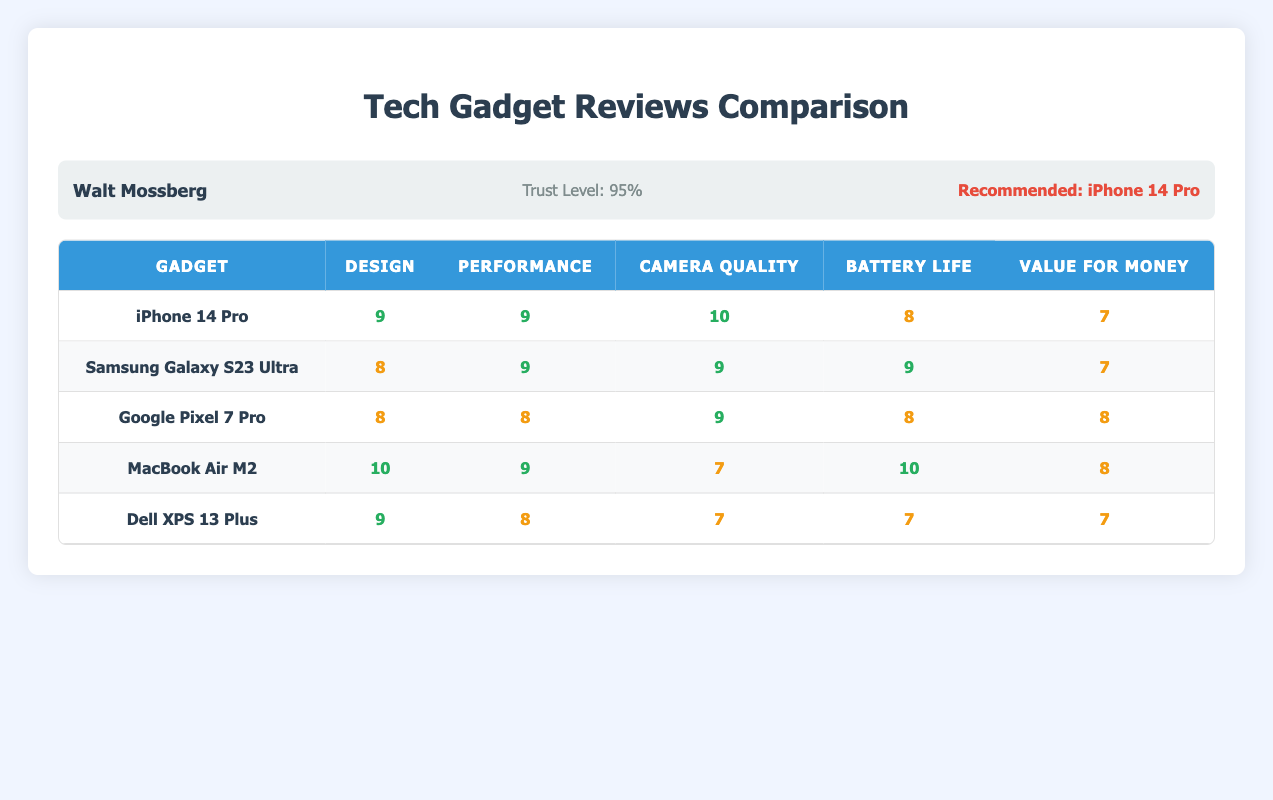What did Walt Mossberg rate the Camera Quality of the iPhone 14 Pro? According to the table, Walt Mossberg rated the Camera Quality of the iPhone 14 Pro as 10.
Answer: 10 Which gadget received the highest overall rating in Design from all columnists? Looking at the Design ratings, the MacBook Air M2 received a score of 10 from Walt Mossberg and a score of 10 from David Pogue, which are the highest ratings for Design across all columnists.
Answer: MacBook Air M2 Does David Pogue think the Samsung Galaxy S23 Ultra has better Camera Quality than the Google Pixel 7 Pro? Yes, David Pogue rated the Camera Quality of the Samsung Galaxy S23 Ultra as 10, while the Google Pixel 7 Pro received a rating of 9 for Camera Quality.
Answer: Yes What is the average Battery Life rating for the Dell XPS 13 Plus? The ratings for the Dell XPS 13 Plus's Battery Life from all columnists are: Walt Mossberg (7), David Pogue (7), Joanna Stern (7), Marques Brownlee (7), and Lisa Eadicicco (7). Summing these gives 35, and dividing by 5 yields an average of 7.
Answer: 7 Which gadget was recommended by the most columnists? Both the iPhone 14 Pro and the MacBook Air M2 were recommended, but only the iPhone 14 Pro was recommended by two columnists (Walt Mossberg and Joanna Stern), while the MacBook Air M2 was the recommended pick of only David Pogue.
Answer: iPhone 14 Pro What is the difference in the Camera Quality rating between Marques Brownlee's top pick and Lisa Eadicicco's top pick? Marques Brownlee's top pick is the Samsung Galaxy S23 Ultra, rated 10 for Camera Quality, while Lisa Eadicicco’s top pick, the Google Pixel 7 Pro, is rated 9. The difference is 10 - 9 = 1.
Answer: 1 Did any columnist give a higher Value for Money rating to the MacBook Air M2 than to the Dell XPS 13 Plus? Yes, David Pogue rated the MacBook Air M2's Value for Money at 8, while all other columnists rated the Dell XPS 13 Plus at 7 for Value for Money.
Answer: Yes What is the trust level of Lisa Eadicicco? The table indicates Lisa Eadicicco has a trust level of 88%.
Answer: 88% What is the total score of the iPhone 14 Pro for all criteria given by Marques Brownlee? The ratings given by Marques Brownlee for the iPhone 14 Pro are: Design (9), Performance (9), Camera Quality (10), Battery Life (8), and Value for Money (7). Summing these gives 9 + 9 + 10 + 8 + 7 = 43.
Answer: 43 